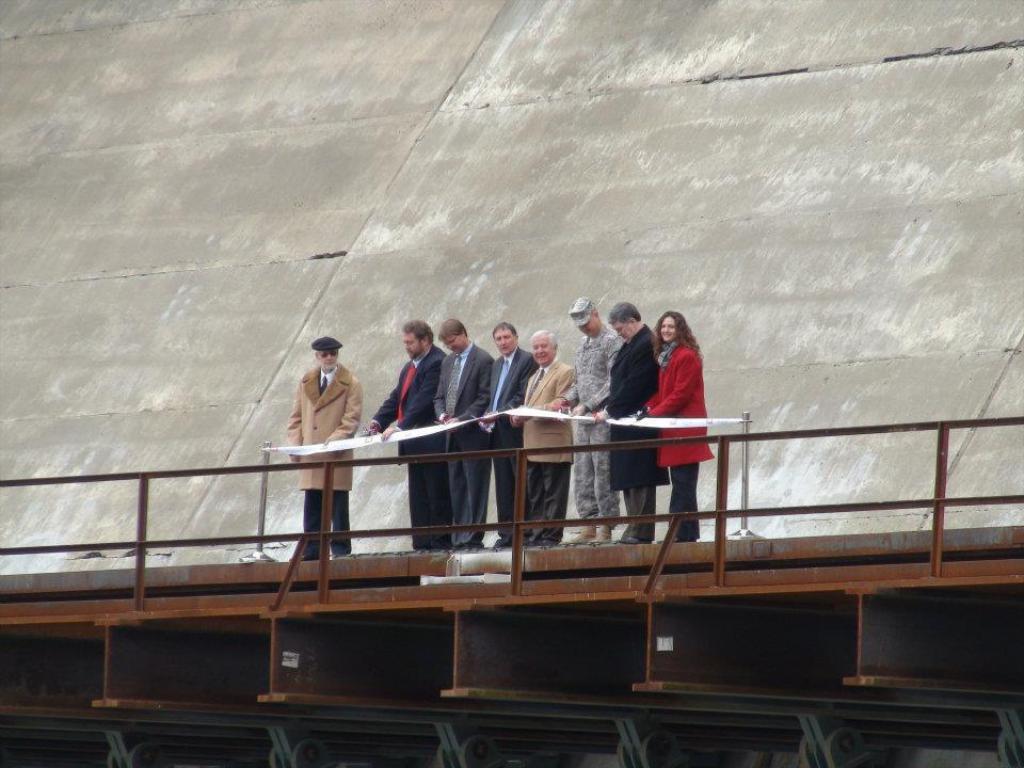How would you summarize this image in a sentence or two? In this image I can see number of persons are standing on the bridge and the metal railing. I can see the grey and white colored background. 